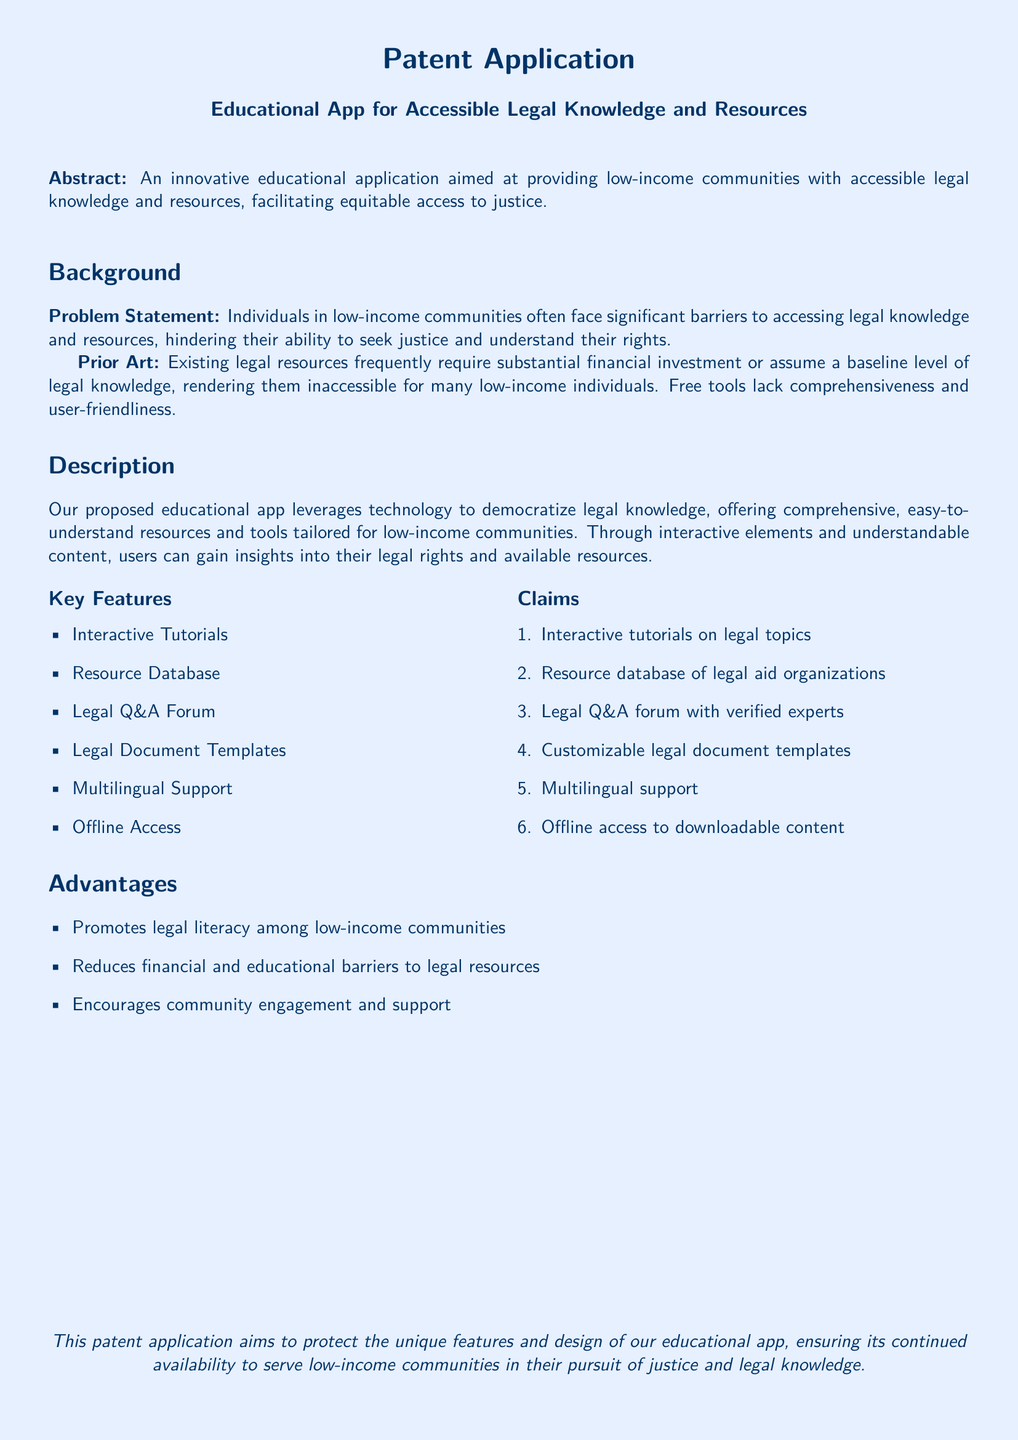What is the purpose of the app? The purpose of the app is to provide low-income communities with accessible legal knowledge and resources, facilitating equitable access to justice.
Answer: Accessible legal knowledge and resources What is a key feature that enhances community engagement? The key feature that enhances community engagement is the Legal Q&A forum, where users can interact with verified experts.
Answer: Legal Q&A forum How many key features are listed in the document? The document lists six key features under the "Key Features" section.
Answer: Six What problem does the app aim to address? The app aims to address barriers to accessing legal knowledge and resources in low-income communities.
Answer: Barriers to accessing legal knowledge What type of support does the app offer for different languages? The app offers multilingual support, ensuring users from diverse backgrounds can access the information.
Answer: Multilingual support What type of documents can users customize using the app? Users can customize legal document templates provided within the app.
Answer: Legal document templates What is the document type of this application? The application is a patent application that aims to protect the features and design of the educational app.
Answer: Patent application What key benefit is associated with the educational app? The key benefit associated with the educational app is promoting legal literacy among low-income communities.
Answer: Promotes legal literacy 